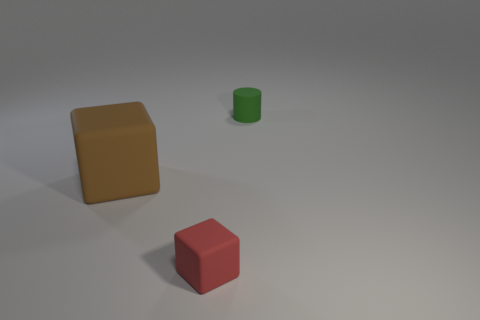Add 3 tiny blue metallic cylinders. How many objects exist? 6 Subtract all cylinders. How many objects are left? 2 Subtract 1 cylinders. How many cylinders are left? 0 Subtract all red blocks. Subtract all yellow cylinders. How many blocks are left? 1 Subtract all yellow balls. How many purple cylinders are left? 0 Subtract all green cylinders. Subtract all rubber cylinders. How many objects are left? 1 Add 1 red objects. How many red objects are left? 2 Add 2 tiny red metallic cylinders. How many tiny red metallic cylinders exist? 2 Subtract all red blocks. How many blocks are left? 1 Subtract 0 brown cylinders. How many objects are left? 3 